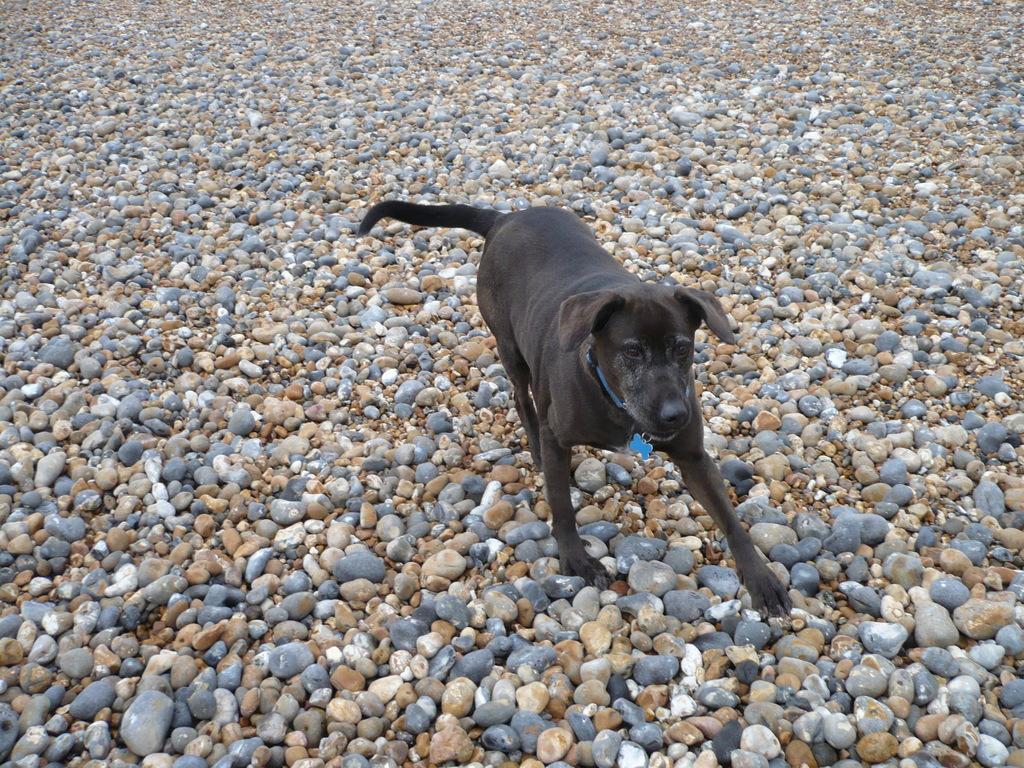Describe this image in one or two sentences. This image consists of a dog in black color. At the bottom, there are stones in different colors. 